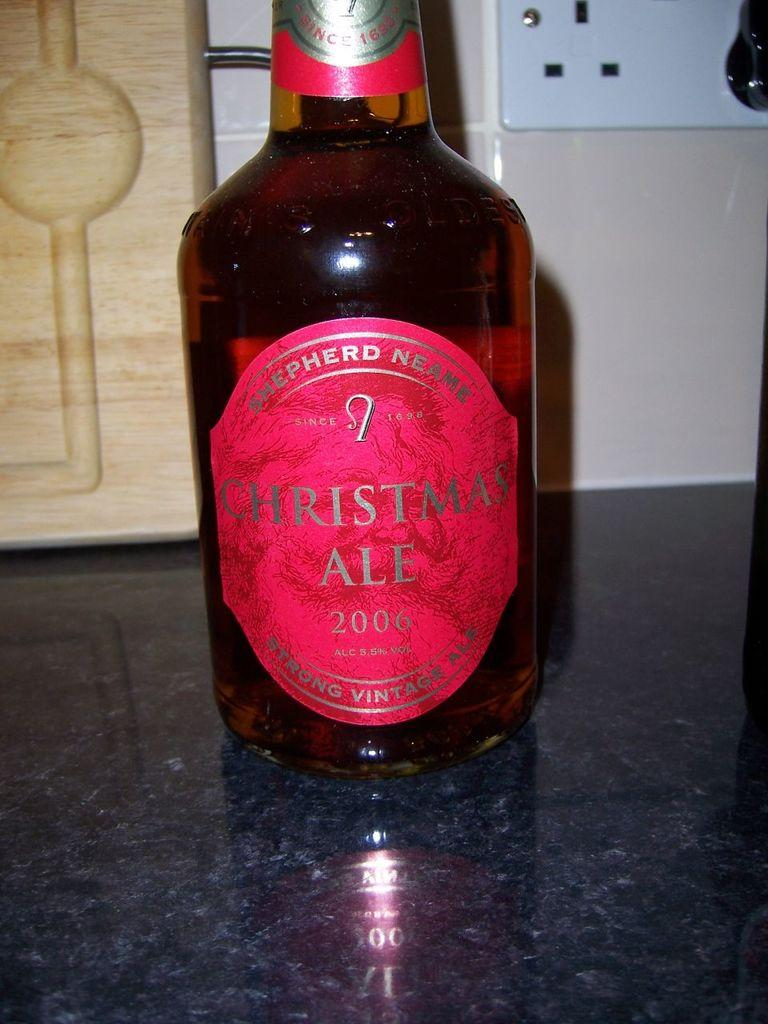Provide a one-sentence caption for the provided image. Shepherd Neame Christmas Ale in a bottle from 2006. 